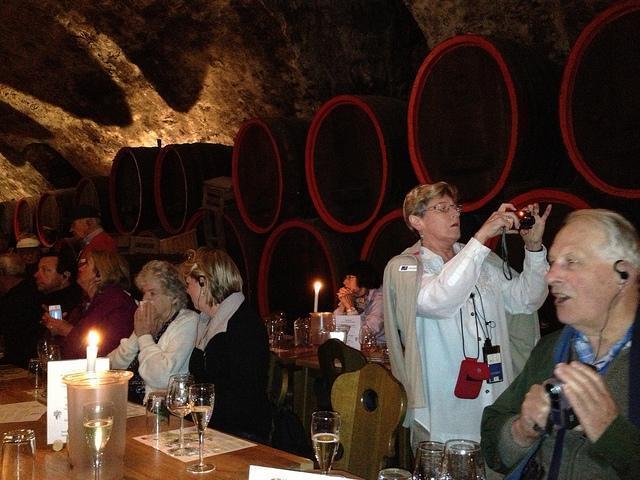What would most likely be stored in this type of location?
Choose the right answer from the provided options to respond to the question.
Options: Alcohol, meat, furniture, produce. Alcohol. 